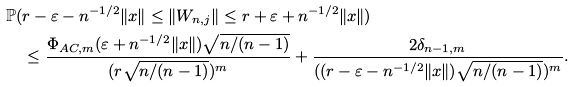Convert formula to latex. <formula><loc_0><loc_0><loc_500><loc_500>& \mathbb { P } ( r - \varepsilon - n ^ { - 1 / 2 } \| x \| \leq \| W _ { n , j } \| \leq r + \varepsilon + n ^ { - 1 / 2 } \| x \| ) \\ & \quad \leq \frac { \Phi _ { A C , m } ( \varepsilon + n ^ { - 1 / 2 } \| x \| ) \sqrt { n / ( n - 1 ) } } { ( r \sqrt { n / ( n - 1 ) } ) ^ { m } } + \frac { 2 \delta _ { n - 1 , m } } { ( ( r - \varepsilon - n ^ { - 1 / 2 } \| x \| ) \sqrt { n / ( n - 1 ) } ) ^ { m } } .</formula> 